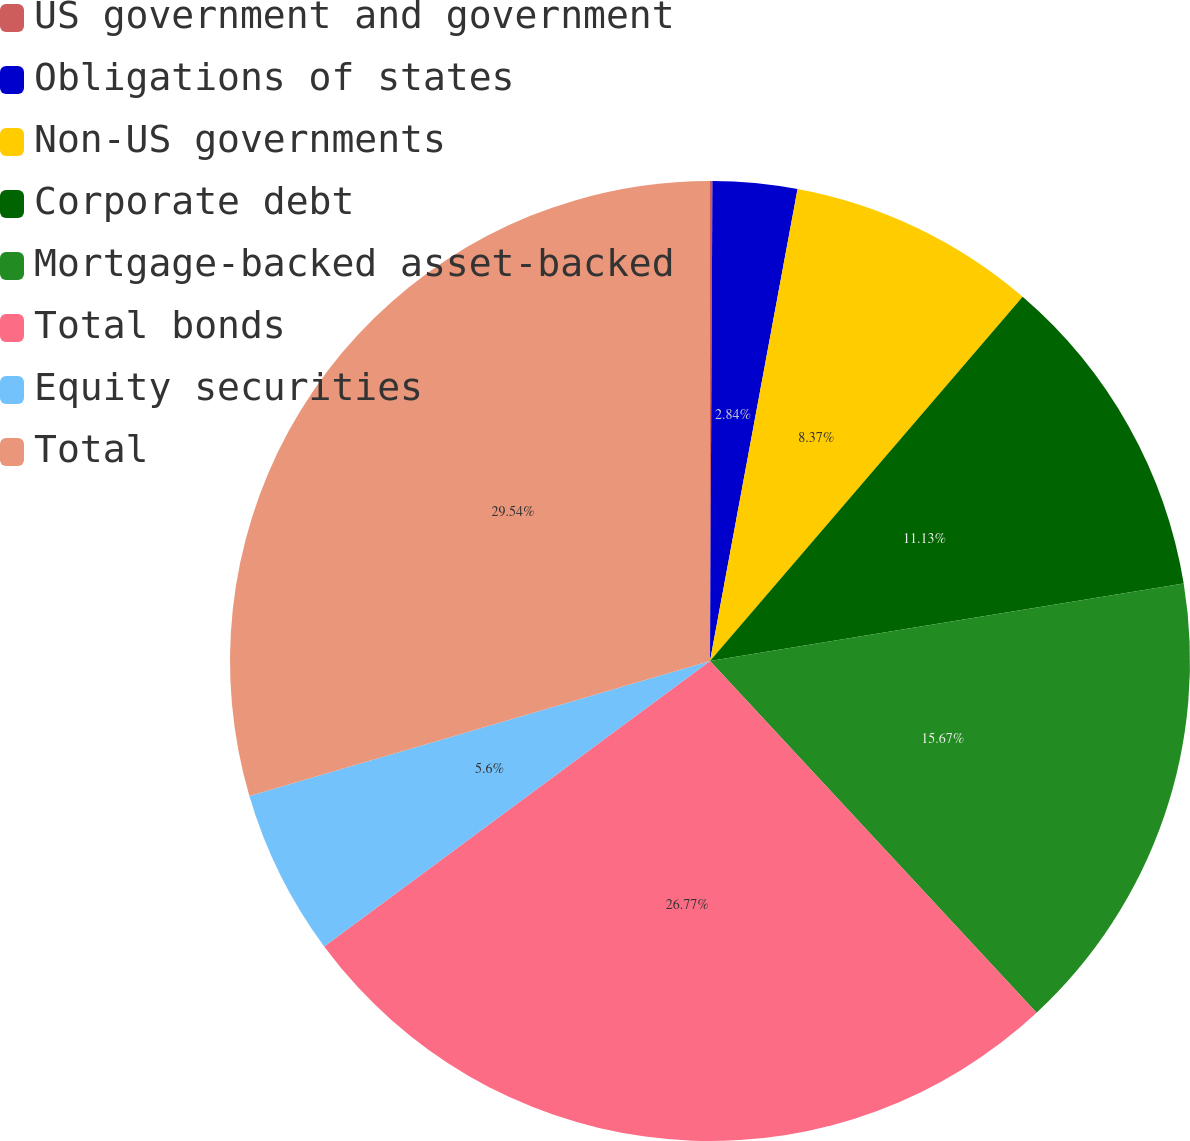Convert chart. <chart><loc_0><loc_0><loc_500><loc_500><pie_chart><fcel>US government and government<fcel>Obligations of states<fcel>Non-US governments<fcel>Corporate debt<fcel>Mortgage-backed asset-backed<fcel>Total bonds<fcel>Equity securities<fcel>Total<nl><fcel>0.08%<fcel>2.84%<fcel>8.37%<fcel>11.13%<fcel>15.67%<fcel>26.77%<fcel>5.6%<fcel>29.54%<nl></chart> 